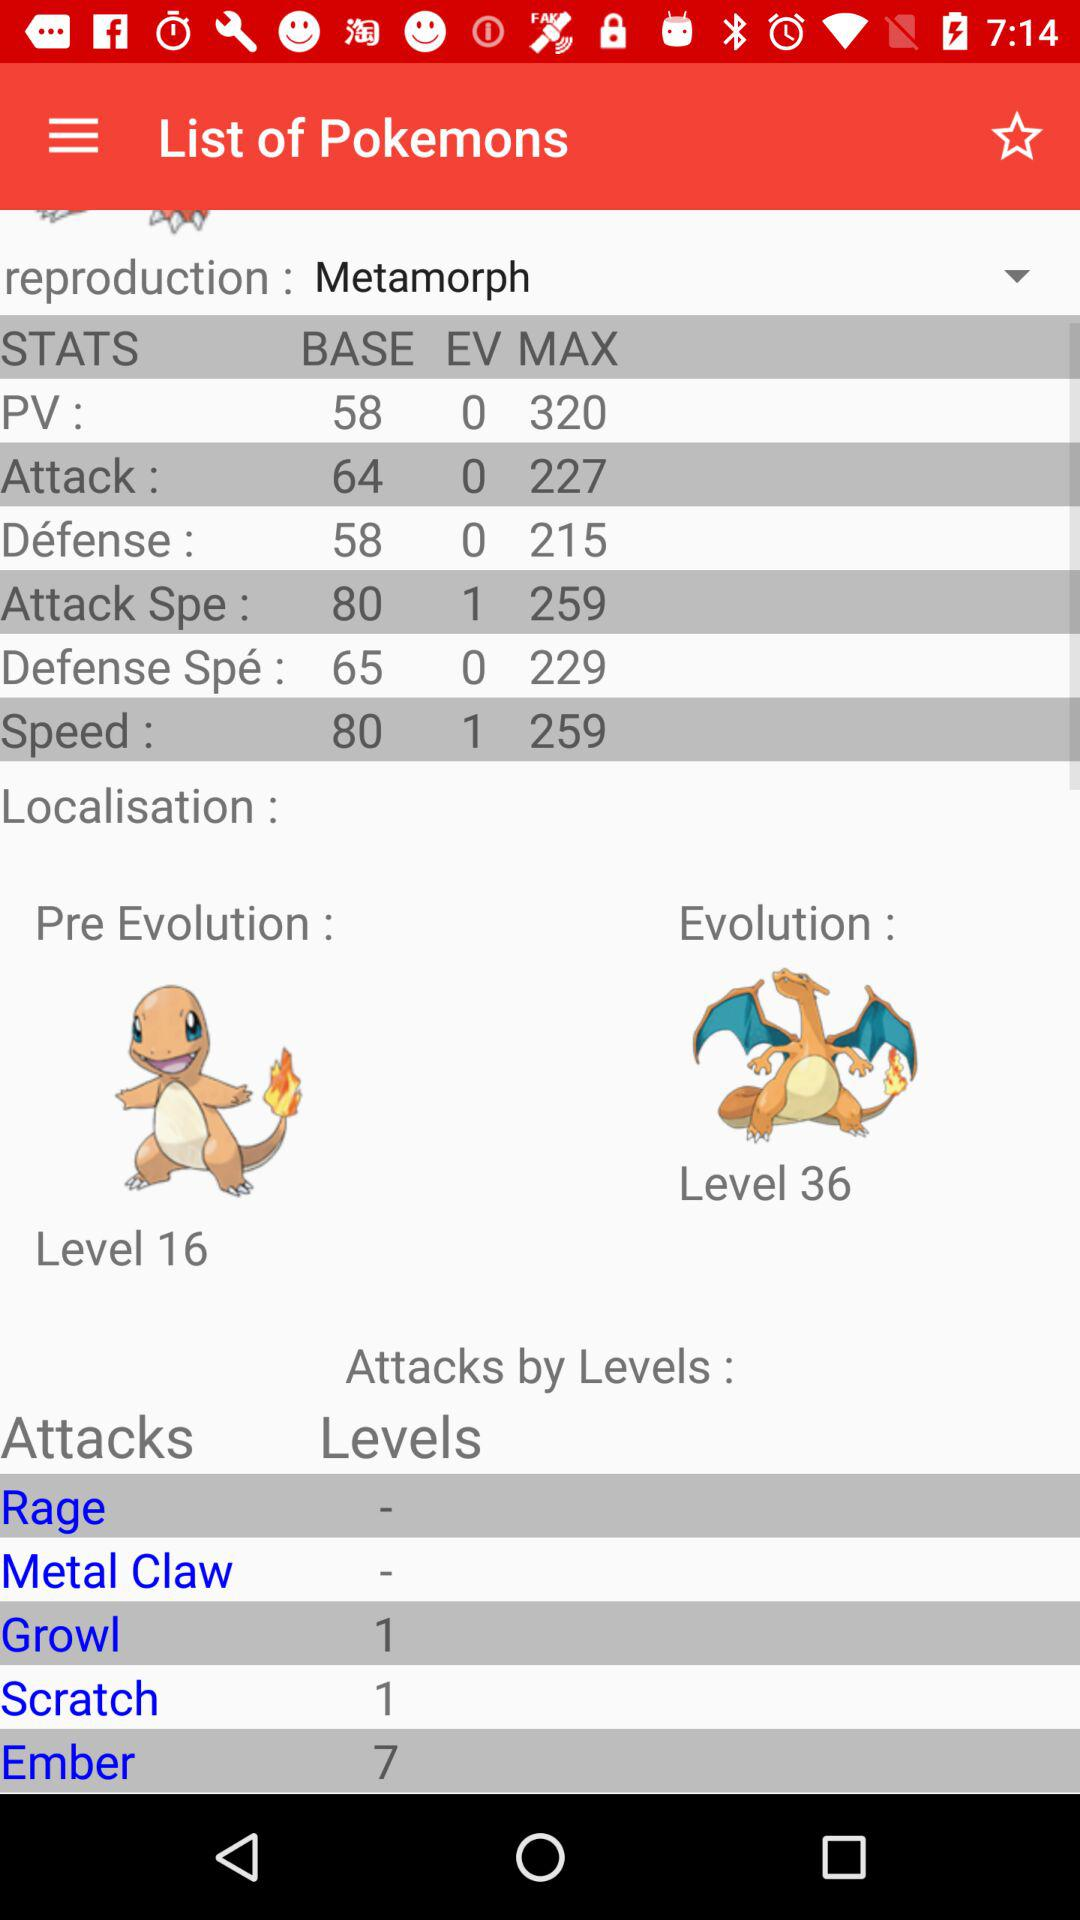Which "STATS" has a base value of 80? The "STATS" that have a base value of 80 are "Attack Spe" and "Speed". 